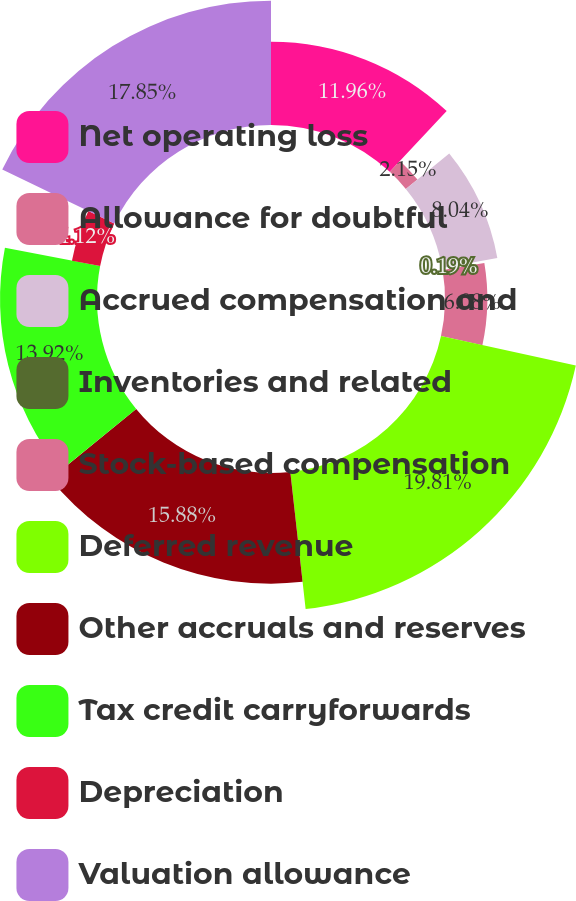Convert chart to OTSL. <chart><loc_0><loc_0><loc_500><loc_500><pie_chart><fcel>Net operating loss<fcel>Allowance for doubtful<fcel>Accrued compensation and<fcel>Inventories and related<fcel>Stock-based compensation<fcel>Deferred revenue<fcel>Other accruals and reserves<fcel>Tax credit carryforwards<fcel>Depreciation<fcel>Valuation allowance<nl><fcel>11.96%<fcel>2.15%<fcel>8.04%<fcel>0.19%<fcel>6.08%<fcel>19.81%<fcel>15.88%<fcel>13.92%<fcel>4.12%<fcel>17.85%<nl></chart> 